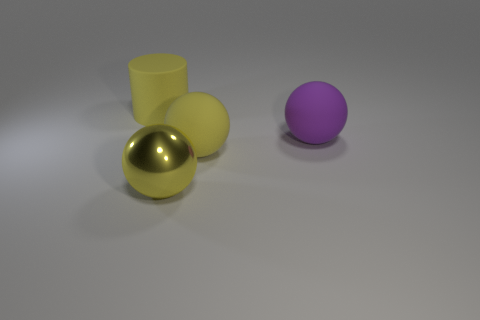Add 1 big yellow metal spheres. How many objects exist? 5 Subtract all spheres. How many objects are left? 1 Subtract all small red metal cylinders. Subtract all large yellow shiny balls. How many objects are left? 3 Add 1 metal objects. How many metal objects are left? 2 Add 2 green cylinders. How many green cylinders exist? 2 Subtract 0 purple cubes. How many objects are left? 4 